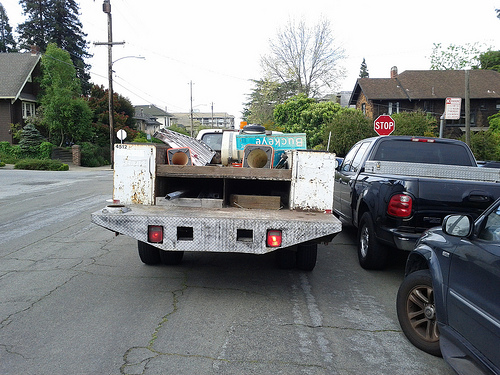How many lights are lit on the back of the white truck in the picture? There are two lights illuminated on the back of the white truck, offering clear visibility to other road users to signal the truck's presence. 